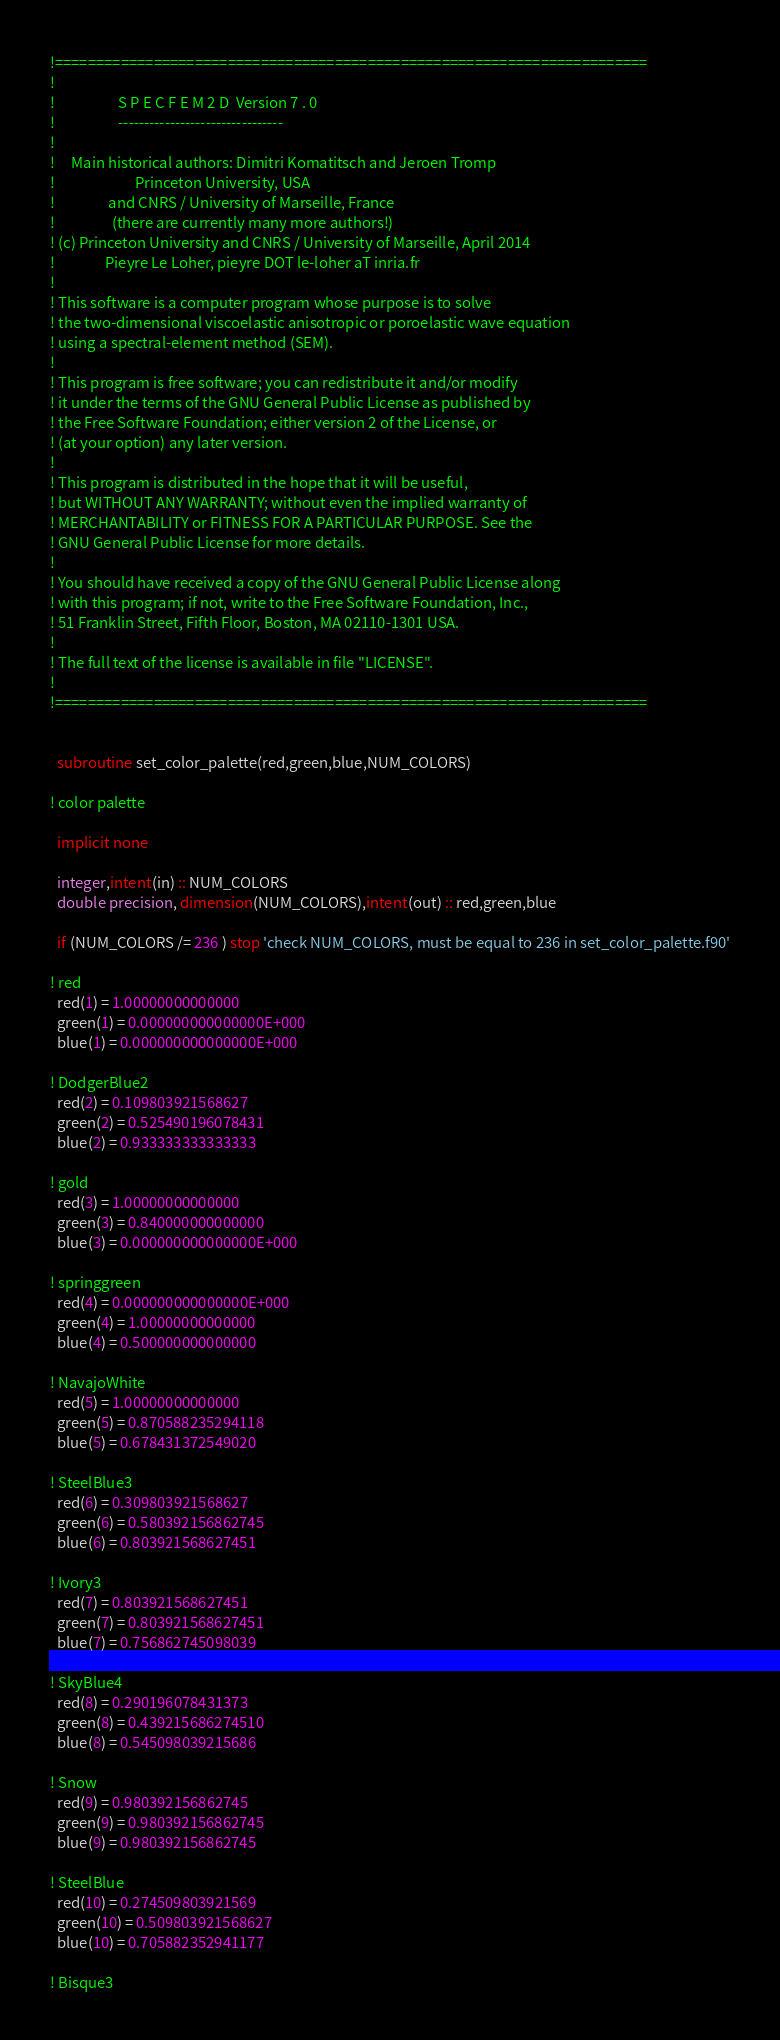<code> <loc_0><loc_0><loc_500><loc_500><_FORTRAN_>!========================================================================
!
!                   S P E C F E M 2 D  Version 7 . 0
!                   --------------------------------
!
!     Main historical authors: Dimitri Komatitsch and Jeroen Tromp
!                        Princeton University, USA
!                and CNRS / University of Marseille, France
!                 (there are currently many more authors!)
! (c) Princeton University and CNRS / University of Marseille, April 2014
!               Pieyre Le Loher, pieyre DOT le-loher aT inria.fr
!
! This software is a computer program whose purpose is to solve
! the two-dimensional viscoelastic anisotropic or poroelastic wave equation
! using a spectral-element method (SEM).
!
! This program is free software; you can redistribute it and/or modify
! it under the terms of the GNU General Public License as published by
! the Free Software Foundation; either version 2 of the License, or
! (at your option) any later version.
!
! This program is distributed in the hope that it will be useful,
! but WITHOUT ANY WARRANTY; without even the implied warranty of
! MERCHANTABILITY or FITNESS FOR A PARTICULAR PURPOSE. See the
! GNU General Public License for more details.
!
! You should have received a copy of the GNU General Public License along
! with this program; if not, write to the Free Software Foundation, Inc.,
! 51 Franklin Street, Fifth Floor, Boston, MA 02110-1301 USA.
!
! The full text of the license is available in file "LICENSE".
!
!========================================================================


  subroutine set_color_palette(red,green,blue,NUM_COLORS)

! color palette

  implicit none

  integer,intent(in) :: NUM_COLORS
  double precision, dimension(NUM_COLORS),intent(out) :: red,green,blue

  if (NUM_COLORS /= 236 ) stop 'check NUM_COLORS, must be equal to 236 in set_color_palette.f90'

! red
  red(1) = 1.00000000000000
  green(1) = 0.000000000000000E+000
  blue(1) = 0.000000000000000E+000

! DodgerBlue2
  red(2) = 0.109803921568627
  green(2) = 0.525490196078431
  blue(2) = 0.933333333333333

! gold
  red(3) = 1.00000000000000
  green(3) = 0.840000000000000
  blue(3) = 0.000000000000000E+000

! springgreen
  red(4) = 0.000000000000000E+000
  green(4) = 1.00000000000000
  blue(4) = 0.500000000000000

! NavajoWhite
  red(5) = 1.00000000000000
  green(5) = 0.870588235294118
  blue(5) = 0.678431372549020

! SteelBlue3
  red(6) = 0.309803921568627
  green(6) = 0.580392156862745
  blue(6) = 0.803921568627451

! Ivory3
  red(7) = 0.803921568627451
  green(7) = 0.803921568627451
  blue(7) = 0.756862745098039

! SkyBlue4
  red(8) = 0.290196078431373
  green(8) = 0.439215686274510
  blue(8) = 0.545098039215686

! Snow
  red(9) = 0.980392156862745
  green(9) = 0.980392156862745
  blue(9) = 0.980392156862745

! SteelBlue
  red(10) = 0.274509803921569
  green(10) = 0.509803921568627
  blue(10) = 0.705882352941177

! Bisque3</code> 